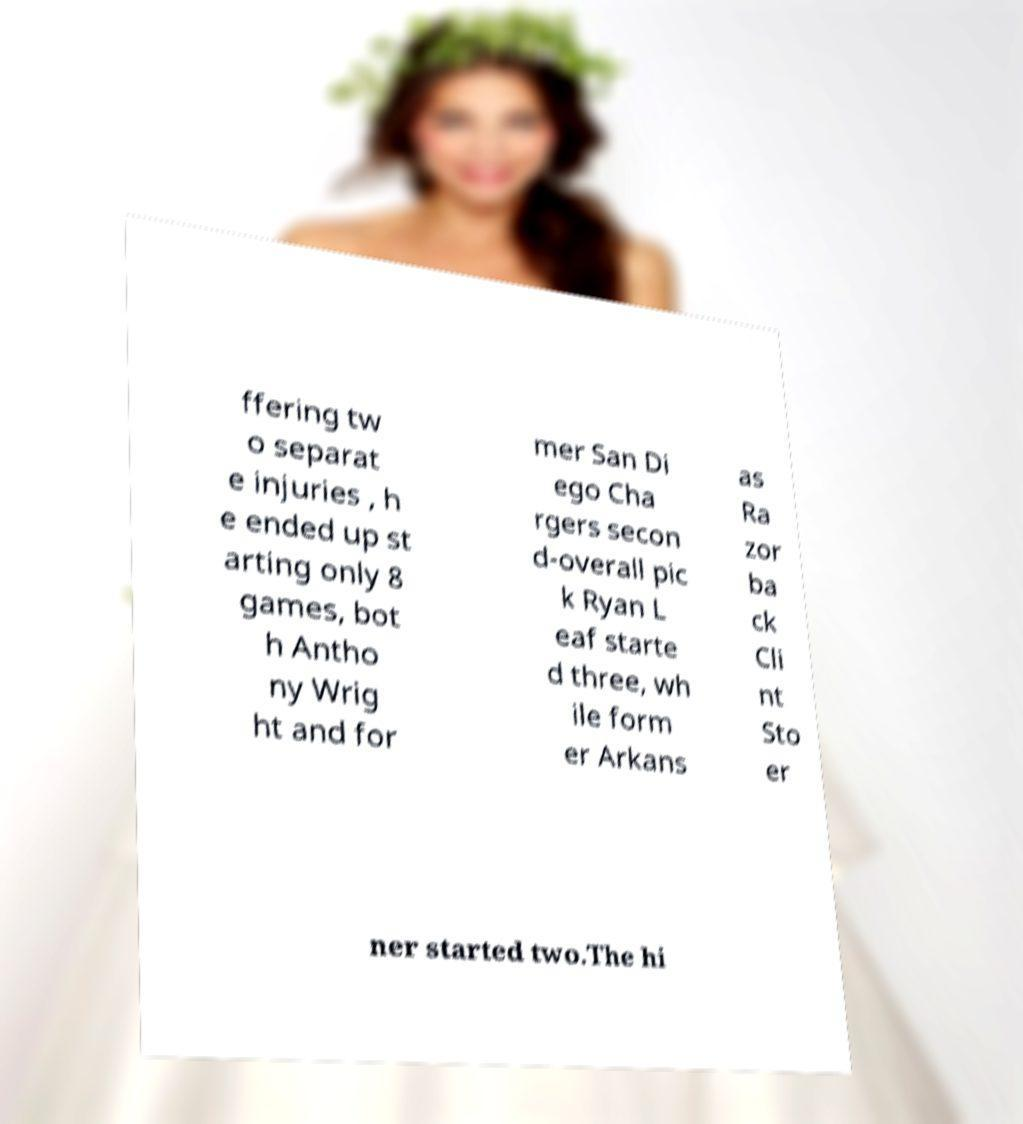Could you assist in decoding the text presented in this image and type it out clearly? ffering tw o separat e injuries , h e ended up st arting only 8 games, bot h Antho ny Wrig ht and for mer San Di ego Cha rgers secon d-overall pic k Ryan L eaf starte d three, wh ile form er Arkans as Ra zor ba ck Cli nt Sto er ner started two.The hi 